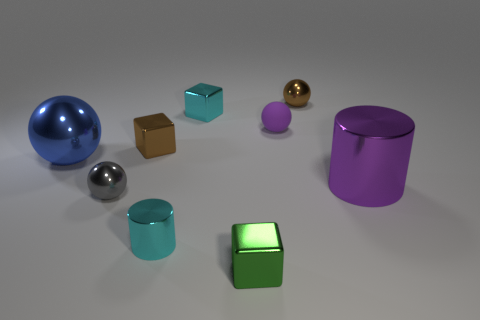Is there anything else of the same color as the large metallic sphere? While there are various objects of different colors in the image, none match the color of the large metallic sphere exactly. However, the smaller sphere appears to be a similar hue but a different tone, showcasing a diversity of colors among the objects presented. 